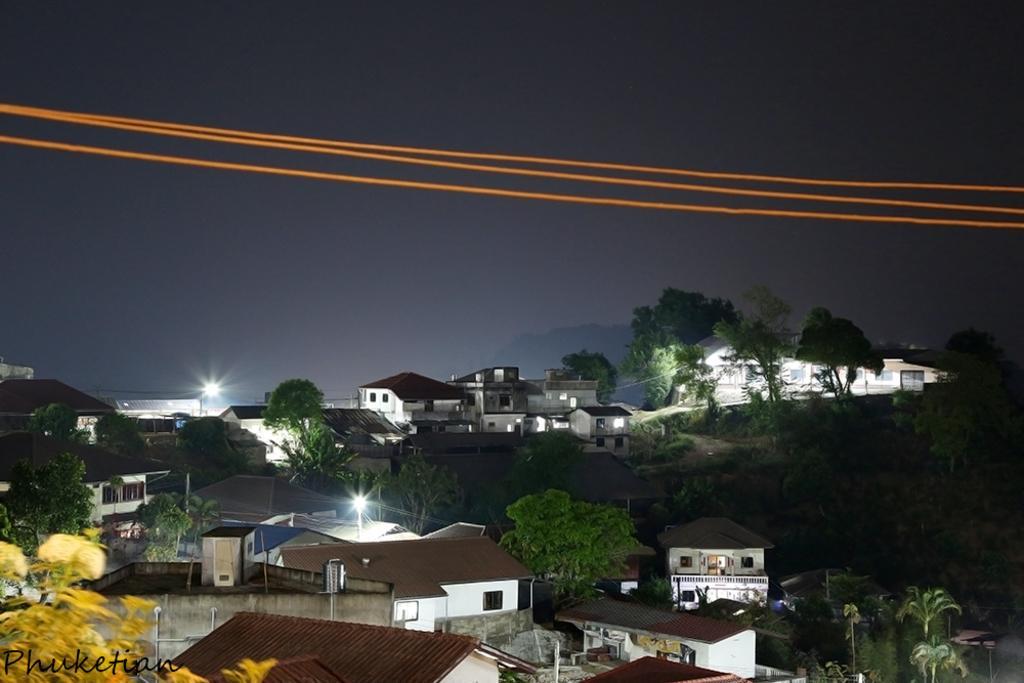Could you give a brief overview of what you see in this image? this image is clicked from a top view. There are houses and trees in the image. Beside the houses there are street light poles. At the top there is the sky. In the bottom left there is text on the image. There are wires in the air. 